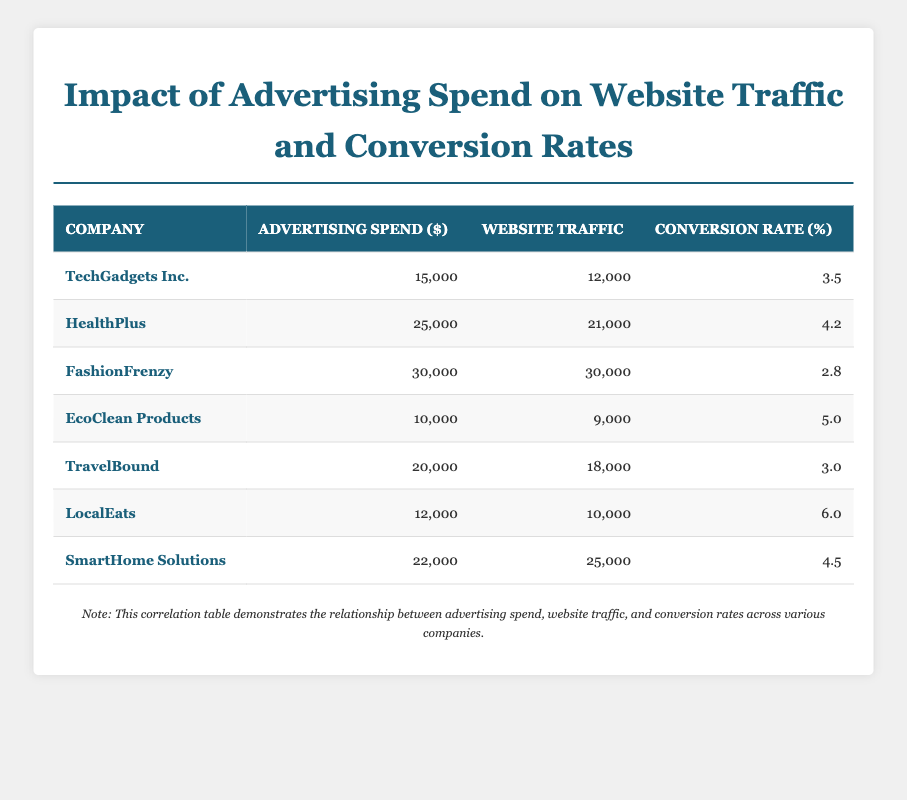What is the Advertising Spend for HealthPlus? The table lists the Advertising Spend for each company, and for HealthPlus, it shows an amount of 25,000.
Answer: 25,000 Which company has the highest Conversion Rate? By reviewing the Conversion Rates listed, we can see the highest value is 6.0 for LocalEats.
Answer: LocalEats What is the average Advertising Spend for all companies? To find the average, we sum the Advertising Spend values: 15,000 + 25,000 + 30,000 + 10,000 + 20,000 + 12,000 + 22,000 = 134,000. Then, we divide by the number of companies, which is 7: 134,000 / 7 = 19,142.86 (approximately).
Answer: 19,143 Is the Conversion Rate for EcoClean Products higher than that of TravelBound? The Conversion Rate for EcoClean Products is 5.0, while for TravelBound, it is 3.0. Since 5.0 is greater than 3.0, the statement is true.
Answer: Yes What can be said about the relationship between Advertising Spend and Website Traffic for FashionFrenzy? For FashionFrenzy, the Advertising Spend is 30,000, and the Website Traffic is also 30,000. This indicates that the company has a significant return on investment in terms of traffic, aligning the spend directly with the traffic received.
Answer: It shows a direct correlation in this case What is the total Website Traffic for all companies combined? To find the total, we add the Website Traffic values: 12,000 + 21,000 + 30,000 + 9,000 + 18,000 + 10,000 + 25,000 = 125,000.
Answer: 125,000 Which company has the lowest Advertising Spend, and what is that amount? EcoClean Products has the lowest Advertising Spend listed at 10,000. This can be determined by comparing all values in the Advertising Spend column.
Answer: 10,000 If the Advertising Spend of SmartHome Solutions were increased by 5,000, what would its new Conversion Rate need to be to maintain the same proportion of Conversion Rate to Website Traffic? Currently, SmartHome Solutions has an Advertising Spend of 22,000, a Website Traffic of 25,000, and a Conversion Rate of 4.5. The proportion of Conversion Rate to Website Traffic is calculated as (4.5/25,000). If its Advertising Spend is increased to 27,000 and we want to maintain the same proportion, we would set up the equation: (x/25,000) = (4.5/22,000). Solving for x gives us the new required Conversion Rate approximately as 6.38%.
Answer: 6.38% 